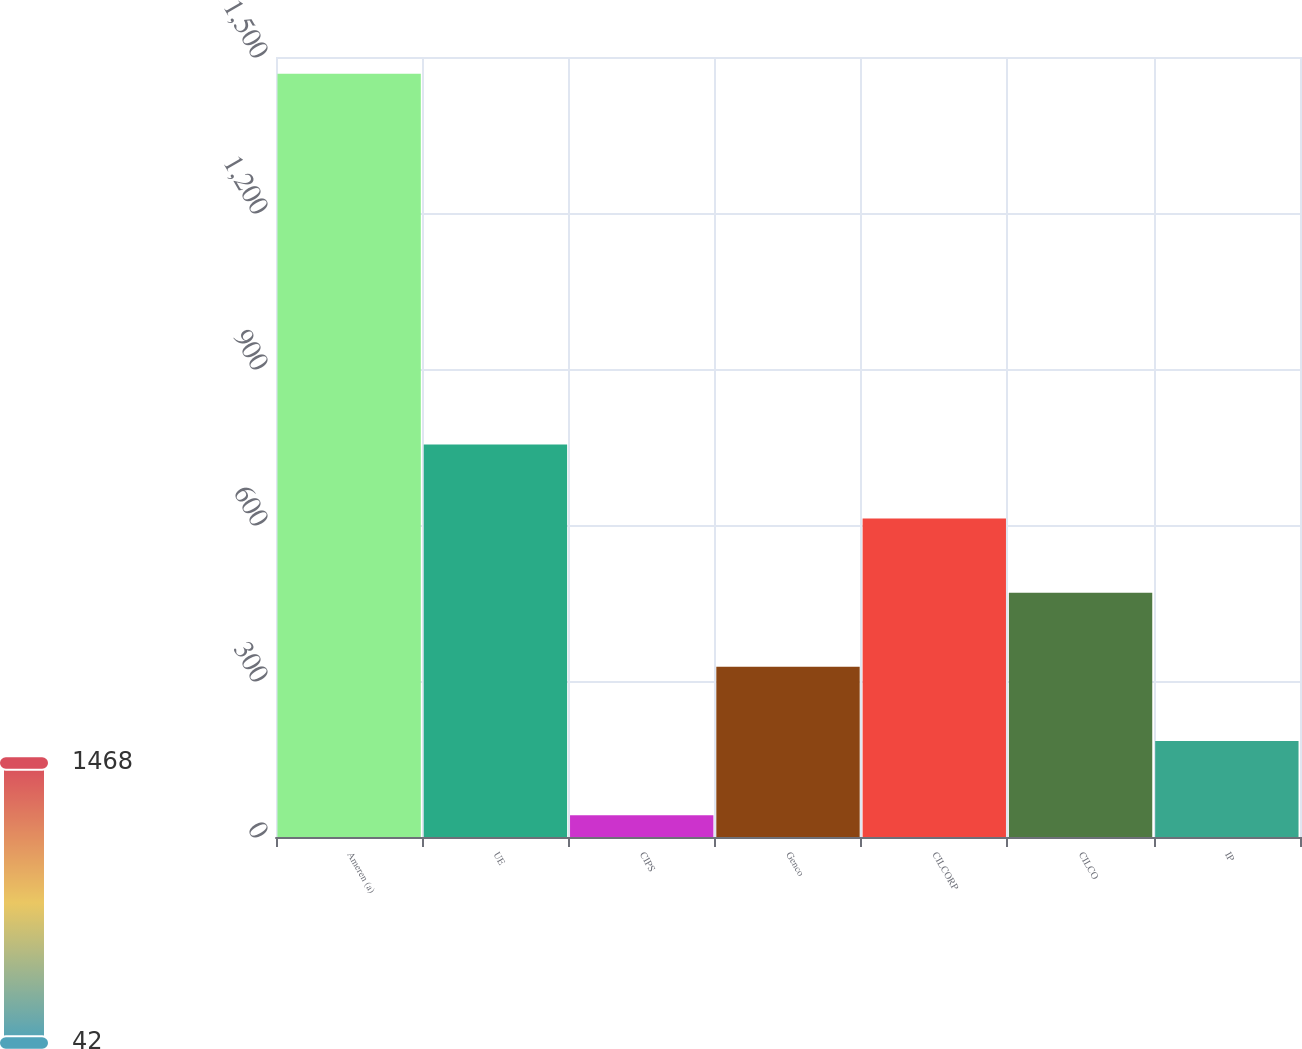Convert chart. <chart><loc_0><loc_0><loc_500><loc_500><bar_chart><fcel>Ameren (a)<fcel>UE<fcel>CIPS<fcel>Genco<fcel>CILCORP<fcel>CILCO<fcel>IP<nl><fcel>1468<fcel>755<fcel>42<fcel>327.2<fcel>612.4<fcel>469.8<fcel>184.6<nl></chart> 